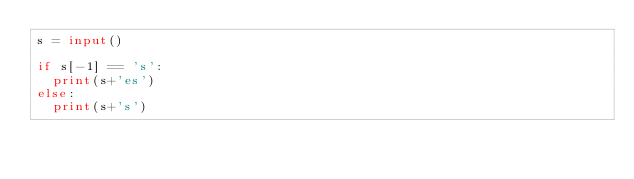Convert code to text. <code><loc_0><loc_0><loc_500><loc_500><_Python_>s = input()

if s[-1] == 's':
  print(s+'es')
else:
  print(s+'s')</code> 